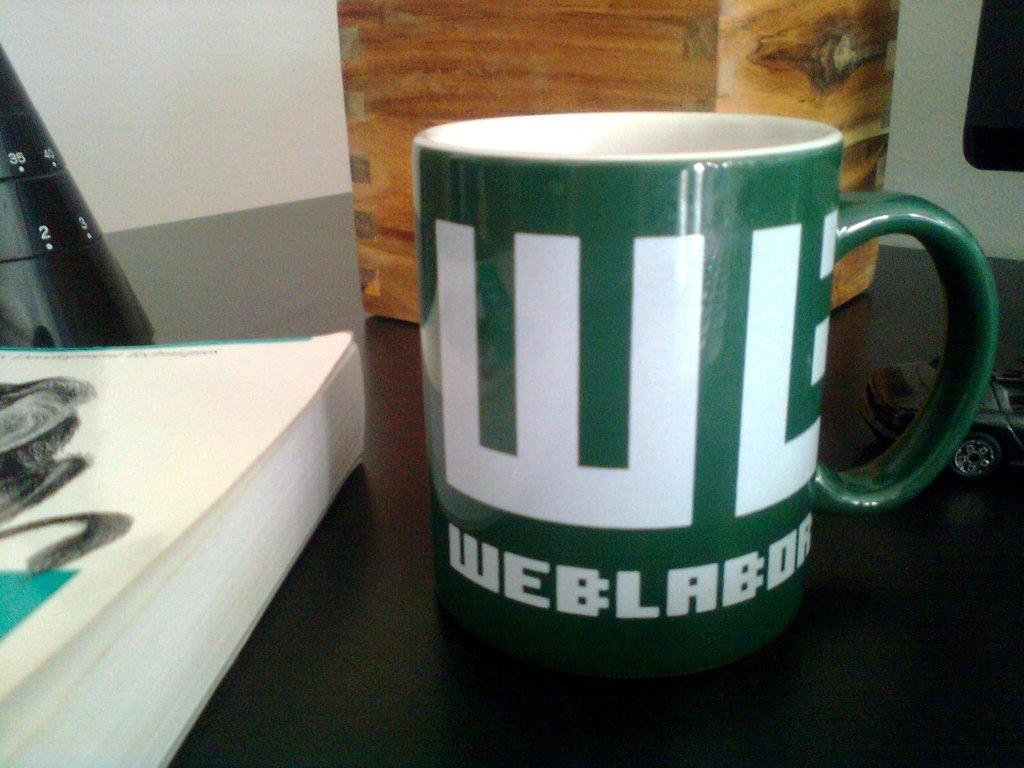<image>
Create a compact narrative representing the image presented. A green mug which has the word weblabor on the bottom. 